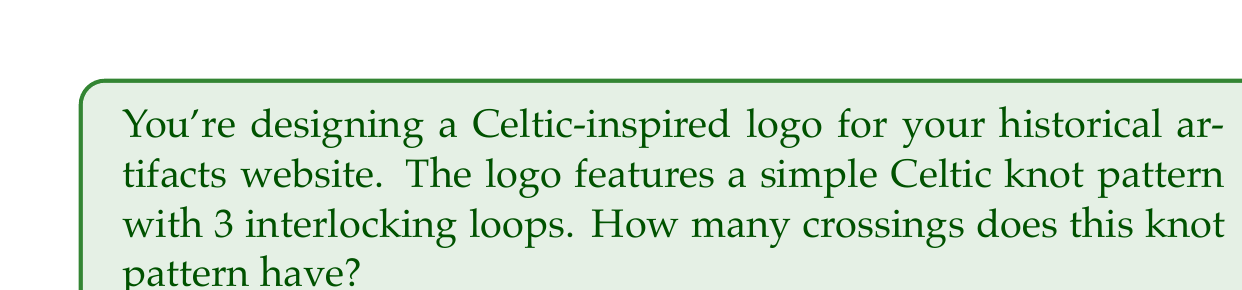Provide a solution to this math problem. To calculate the crossing number of a Celtic knot pattern, we need to count the number of times the strands cross over or under each other. Let's approach this step-by-step:

1. Visualize the knot:
   A simple Celtic knot with 3 interlocking loops typically forms a trefoil-like pattern.

2. Trace the path:
   Start at any point and follow the strand, counting each crossing.

3. Count the crossings:
   - Each loop intersects with the other two loops.
   - Each intersection creates two crossings (over and under).
   - With 3 loops, we have 3 intersections.

4. Calculate:
   $$ \text{Total crossings} = \text{Number of intersections} \times \text{Crossings per intersection} $$
   $$ = 3 \times 2 = 6 $$

Therefore, this simple Celtic knot pattern with 3 interlocking loops has 6 crossings.
Answer: 6 crossings 